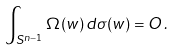<formula> <loc_0><loc_0><loc_500><loc_500>\int _ { S ^ { n - 1 } } \Omega ( w ) \, d \sigma ( w ) = O \, .</formula> 